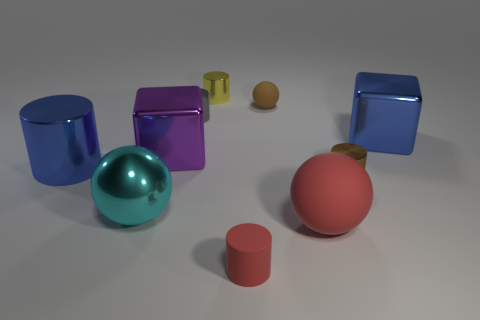There is a tiny matte thing on the right side of the tiny red matte thing; does it have the same shape as the large blue shiny object in front of the large purple shiny thing?
Provide a short and direct response. No. What number of other objects are the same size as the red cylinder?
Offer a very short reply. 4. What size is the purple cube?
Offer a terse response. Large. Does the red thing left of the large rubber thing have the same material as the small yellow object?
Keep it short and to the point. No. What is the color of the other rubber object that is the same shape as the brown rubber thing?
Provide a short and direct response. Red. Do the tiny shiny object that is behind the gray thing and the rubber cylinder have the same color?
Offer a very short reply. No. Are there any small metal cylinders to the right of the tiny brown rubber sphere?
Keep it short and to the point. Yes. What color is the matte object that is right of the small red matte cylinder and in front of the blue metallic block?
Your answer should be compact. Red. What shape is the matte object that is the same color as the large rubber ball?
Offer a very short reply. Cylinder. There is a red object that is on the right side of the small matte object in front of the blue cylinder; what size is it?
Offer a very short reply. Large. 